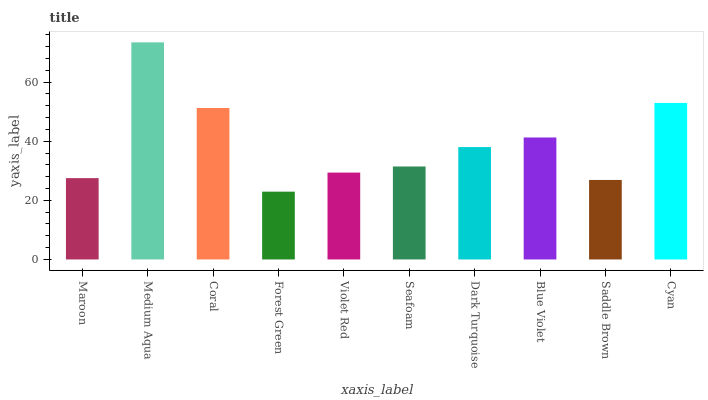Is Forest Green the minimum?
Answer yes or no. Yes. Is Medium Aqua the maximum?
Answer yes or no. Yes. Is Coral the minimum?
Answer yes or no. No. Is Coral the maximum?
Answer yes or no. No. Is Medium Aqua greater than Coral?
Answer yes or no. Yes. Is Coral less than Medium Aqua?
Answer yes or no. Yes. Is Coral greater than Medium Aqua?
Answer yes or no. No. Is Medium Aqua less than Coral?
Answer yes or no. No. Is Dark Turquoise the high median?
Answer yes or no. Yes. Is Seafoam the low median?
Answer yes or no. Yes. Is Coral the high median?
Answer yes or no. No. Is Cyan the low median?
Answer yes or no. No. 